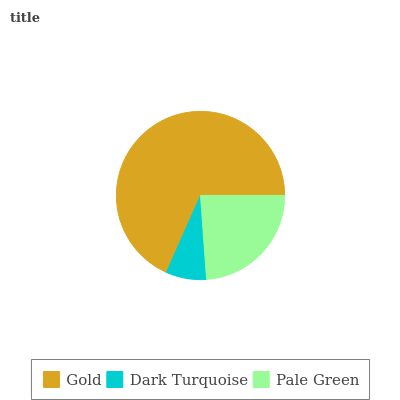Is Dark Turquoise the minimum?
Answer yes or no. Yes. Is Gold the maximum?
Answer yes or no. Yes. Is Pale Green the minimum?
Answer yes or no. No. Is Pale Green the maximum?
Answer yes or no. No. Is Pale Green greater than Dark Turquoise?
Answer yes or no. Yes. Is Dark Turquoise less than Pale Green?
Answer yes or no. Yes. Is Dark Turquoise greater than Pale Green?
Answer yes or no. No. Is Pale Green less than Dark Turquoise?
Answer yes or no. No. Is Pale Green the high median?
Answer yes or no. Yes. Is Pale Green the low median?
Answer yes or no. Yes. Is Dark Turquoise the high median?
Answer yes or no. No. Is Dark Turquoise the low median?
Answer yes or no. No. 